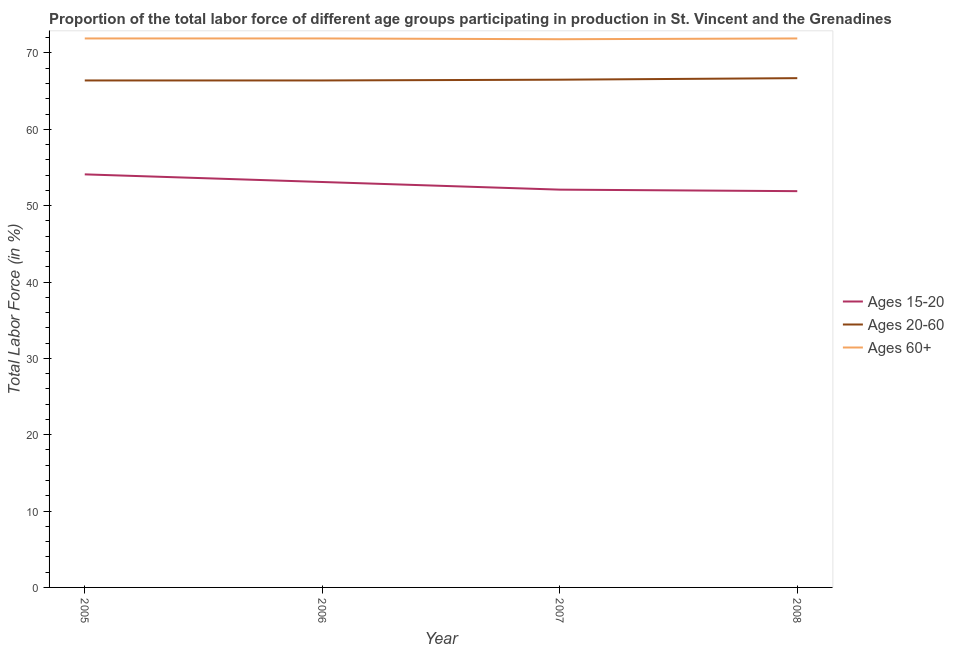Does the line corresponding to percentage of labor force within the age group 20-60 intersect with the line corresponding to percentage of labor force above age 60?
Your response must be concise. No. What is the percentage of labor force within the age group 20-60 in 2008?
Provide a succinct answer. 66.7. Across all years, what is the maximum percentage of labor force within the age group 20-60?
Provide a short and direct response. 66.7. Across all years, what is the minimum percentage of labor force within the age group 15-20?
Keep it short and to the point. 51.9. What is the total percentage of labor force within the age group 15-20 in the graph?
Make the answer very short. 211.2. What is the difference between the percentage of labor force within the age group 20-60 in 2005 and that in 2006?
Make the answer very short. 0. What is the difference between the percentage of labor force within the age group 15-20 in 2008 and the percentage of labor force above age 60 in 2007?
Your answer should be very brief. -19.9. What is the average percentage of labor force within the age group 15-20 per year?
Your answer should be compact. 52.8. In the year 2008, what is the difference between the percentage of labor force within the age group 20-60 and percentage of labor force within the age group 15-20?
Provide a short and direct response. 14.8. What is the ratio of the percentage of labor force within the age group 15-20 in 2005 to that in 2006?
Provide a short and direct response. 1.02. What is the difference between the highest and the second highest percentage of labor force within the age group 20-60?
Offer a very short reply. 0.2. What is the difference between the highest and the lowest percentage of labor force above age 60?
Offer a very short reply. 0.1. In how many years, is the percentage of labor force within the age group 20-60 greater than the average percentage of labor force within the age group 20-60 taken over all years?
Offer a very short reply. 1. Is the sum of the percentage of labor force above age 60 in 2005 and 2008 greater than the maximum percentage of labor force within the age group 15-20 across all years?
Ensure brevity in your answer.  Yes. Is the percentage of labor force above age 60 strictly greater than the percentage of labor force within the age group 20-60 over the years?
Your answer should be compact. Yes. Is the percentage of labor force within the age group 15-20 strictly less than the percentage of labor force within the age group 20-60 over the years?
Provide a short and direct response. Yes. How many lines are there?
Provide a succinct answer. 3. What is the difference between two consecutive major ticks on the Y-axis?
Provide a succinct answer. 10. Are the values on the major ticks of Y-axis written in scientific E-notation?
Make the answer very short. No. Does the graph contain any zero values?
Ensure brevity in your answer.  No. What is the title of the graph?
Provide a short and direct response. Proportion of the total labor force of different age groups participating in production in St. Vincent and the Grenadines. Does "Industrial Nitrous Oxide" appear as one of the legend labels in the graph?
Make the answer very short. No. What is the label or title of the X-axis?
Keep it short and to the point. Year. What is the Total Labor Force (in %) of Ages 15-20 in 2005?
Offer a terse response. 54.1. What is the Total Labor Force (in %) in Ages 20-60 in 2005?
Make the answer very short. 66.4. What is the Total Labor Force (in %) of Ages 60+ in 2005?
Ensure brevity in your answer.  71.9. What is the Total Labor Force (in %) of Ages 15-20 in 2006?
Provide a short and direct response. 53.1. What is the Total Labor Force (in %) in Ages 20-60 in 2006?
Offer a terse response. 66.4. What is the Total Labor Force (in %) in Ages 60+ in 2006?
Offer a terse response. 71.9. What is the Total Labor Force (in %) of Ages 15-20 in 2007?
Offer a very short reply. 52.1. What is the Total Labor Force (in %) in Ages 20-60 in 2007?
Make the answer very short. 66.5. What is the Total Labor Force (in %) in Ages 60+ in 2007?
Make the answer very short. 71.8. What is the Total Labor Force (in %) in Ages 15-20 in 2008?
Offer a terse response. 51.9. What is the Total Labor Force (in %) of Ages 20-60 in 2008?
Ensure brevity in your answer.  66.7. What is the Total Labor Force (in %) of Ages 60+ in 2008?
Make the answer very short. 71.9. Across all years, what is the maximum Total Labor Force (in %) in Ages 15-20?
Make the answer very short. 54.1. Across all years, what is the maximum Total Labor Force (in %) in Ages 20-60?
Ensure brevity in your answer.  66.7. Across all years, what is the maximum Total Labor Force (in %) of Ages 60+?
Offer a terse response. 71.9. Across all years, what is the minimum Total Labor Force (in %) in Ages 15-20?
Provide a short and direct response. 51.9. Across all years, what is the minimum Total Labor Force (in %) in Ages 20-60?
Your answer should be very brief. 66.4. Across all years, what is the minimum Total Labor Force (in %) of Ages 60+?
Your answer should be compact. 71.8. What is the total Total Labor Force (in %) in Ages 15-20 in the graph?
Your response must be concise. 211.2. What is the total Total Labor Force (in %) of Ages 20-60 in the graph?
Your answer should be very brief. 266. What is the total Total Labor Force (in %) of Ages 60+ in the graph?
Make the answer very short. 287.5. What is the difference between the Total Labor Force (in %) of Ages 20-60 in 2005 and that in 2006?
Provide a short and direct response. 0. What is the difference between the Total Labor Force (in %) of Ages 20-60 in 2005 and that in 2007?
Provide a short and direct response. -0.1. What is the difference between the Total Labor Force (in %) of Ages 60+ in 2005 and that in 2007?
Make the answer very short. 0.1. What is the difference between the Total Labor Force (in %) of Ages 15-20 in 2006 and that in 2007?
Provide a short and direct response. 1. What is the difference between the Total Labor Force (in %) of Ages 20-60 in 2006 and that in 2007?
Provide a succinct answer. -0.1. What is the difference between the Total Labor Force (in %) in Ages 15-20 in 2006 and that in 2008?
Make the answer very short. 1.2. What is the difference between the Total Labor Force (in %) in Ages 20-60 in 2006 and that in 2008?
Keep it short and to the point. -0.3. What is the difference between the Total Labor Force (in %) of Ages 60+ in 2006 and that in 2008?
Make the answer very short. 0. What is the difference between the Total Labor Force (in %) of Ages 15-20 in 2005 and the Total Labor Force (in %) of Ages 60+ in 2006?
Give a very brief answer. -17.8. What is the difference between the Total Labor Force (in %) of Ages 20-60 in 2005 and the Total Labor Force (in %) of Ages 60+ in 2006?
Make the answer very short. -5.5. What is the difference between the Total Labor Force (in %) in Ages 15-20 in 2005 and the Total Labor Force (in %) in Ages 20-60 in 2007?
Your answer should be compact. -12.4. What is the difference between the Total Labor Force (in %) in Ages 15-20 in 2005 and the Total Labor Force (in %) in Ages 60+ in 2007?
Offer a terse response. -17.7. What is the difference between the Total Labor Force (in %) of Ages 15-20 in 2005 and the Total Labor Force (in %) of Ages 20-60 in 2008?
Provide a short and direct response. -12.6. What is the difference between the Total Labor Force (in %) of Ages 15-20 in 2005 and the Total Labor Force (in %) of Ages 60+ in 2008?
Give a very brief answer. -17.8. What is the difference between the Total Labor Force (in %) in Ages 20-60 in 2005 and the Total Labor Force (in %) in Ages 60+ in 2008?
Provide a succinct answer. -5.5. What is the difference between the Total Labor Force (in %) in Ages 15-20 in 2006 and the Total Labor Force (in %) in Ages 60+ in 2007?
Your answer should be very brief. -18.7. What is the difference between the Total Labor Force (in %) of Ages 15-20 in 2006 and the Total Labor Force (in %) of Ages 60+ in 2008?
Ensure brevity in your answer.  -18.8. What is the difference between the Total Labor Force (in %) of Ages 20-60 in 2006 and the Total Labor Force (in %) of Ages 60+ in 2008?
Your answer should be compact. -5.5. What is the difference between the Total Labor Force (in %) in Ages 15-20 in 2007 and the Total Labor Force (in %) in Ages 20-60 in 2008?
Your response must be concise. -14.6. What is the difference between the Total Labor Force (in %) of Ages 15-20 in 2007 and the Total Labor Force (in %) of Ages 60+ in 2008?
Your answer should be very brief. -19.8. What is the difference between the Total Labor Force (in %) in Ages 20-60 in 2007 and the Total Labor Force (in %) in Ages 60+ in 2008?
Give a very brief answer. -5.4. What is the average Total Labor Force (in %) of Ages 15-20 per year?
Your answer should be compact. 52.8. What is the average Total Labor Force (in %) of Ages 20-60 per year?
Your response must be concise. 66.5. What is the average Total Labor Force (in %) of Ages 60+ per year?
Offer a very short reply. 71.88. In the year 2005, what is the difference between the Total Labor Force (in %) in Ages 15-20 and Total Labor Force (in %) in Ages 20-60?
Offer a terse response. -12.3. In the year 2005, what is the difference between the Total Labor Force (in %) in Ages 15-20 and Total Labor Force (in %) in Ages 60+?
Ensure brevity in your answer.  -17.8. In the year 2006, what is the difference between the Total Labor Force (in %) of Ages 15-20 and Total Labor Force (in %) of Ages 60+?
Offer a terse response. -18.8. In the year 2006, what is the difference between the Total Labor Force (in %) in Ages 20-60 and Total Labor Force (in %) in Ages 60+?
Make the answer very short. -5.5. In the year 2007, what is the difference between the Total Labor Force (in %) in Ages 15-20 and Total Labor Force (in %) in Ages 20-60?
Your answer should be compact. -14.4. In the year 2007, what is the difference between the Total Labor Force (in %) of Ages 15-20 and Total Labor Force (in %) of Ages 60+?
Ensure brevity in your answer.  -19.7. In the year 2008, what is the difference between the Total Labor Force (in %) of Ages 15-20 and Total Labor Force (in %) of Ages 20-60?
Give a very brief answer. -14.8. In the year 2008, what is the difference between the Total Labor Force (in %) in Ages 20-60 and Total Labor Force (in %) in Ages 60+?
Keep it short and to the point. -5.2. What is the ratio of the Total Labor Force (in %) of Ages 15-20 in 2005 to that in 2006?
Offer a terse response. 1.02. What is the ratio of the Total Labor Force (in %) of Ages 20-60 in 2005 to that in 2006?
Keep it short and to the point. 1. What is the ratio of the Total Labor Force (in %) of Ages 15-20 in 2005 to that in 2007?
Your answer should be very brief. 1.04. What is the ratio of the Total Labor Force (in %) of Ages 20-60 in 2005 to that in 2007?
Your answer should be compact. 1. What is the ratio of the Total Labor Force (in %) of Ages 60+ in 2005 to that in 2007?
Your answer should be compact. 1. What is the ratio of the Total Labor Force (in %) of Ages 15-20 in 2005 to that in 2008?
Ensure brevity in your answer.  1.04. What is the ratio of the Total Labor Force (in %) of Ages 60+ in 2005 to that in 2008?
Provide a succinct answer. 1. What is the ratio of the Total Labor Force (in %) of Ages 15-20 in 2006 to that in 2007?
Make the answer very short. 1.02. What is the ratio of the Total Labor Force (in %) of Ages 20-60 in 2006 to that in 2007?
Your response must be concise. 1. What is the ratio of the Total Labor Force (in %) in Ages 15-20 in 2006 to that in 2008?
Your answer should be very brief. 1.02. What is the ratio of the Total Labor Force (in %) of Ages 15-20 in 2007 to that in 2008?
Provide a short and direct response. 1. What is the difference between the highest and the second highest Total Labor Force (in %) in Ages 15-20?
Offer a terse response. 1. What is the difference between the highest and the second highest Total Labor Force (in %) in Ages 20-60?
Offer a very short reply. 0.2. What is the difference between the highest and the lowest Total Labor Force (in %) of Ages 15-20?
Give a very brief answer. 2.2. What is the difference between the highest and the lowest Total Labor Force (in %) of Ages 60+?
Provide a succinct answer. 0.1. 